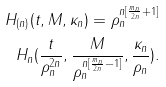Convert formula to latex. <formula><loc_0><loc_0><loc_500><loc_500>H _ { ( n ) } ( t , M , \kappa _ { n } ) = \rho _ { n } ^ { n [ \frac { m _ { n } } { 2 n } + 1 ] } \\ \, H _ { n } ( \frac { t } { \rho _ { n } ^ { 2 n } } , \frac { M } { \rho _ { n } ^ { n [ \frac { m _ { n } } { 2 n } - 1 ] } } , \frac { \kappa _ { n } } { \rho _ { n } } ) .</formula> 